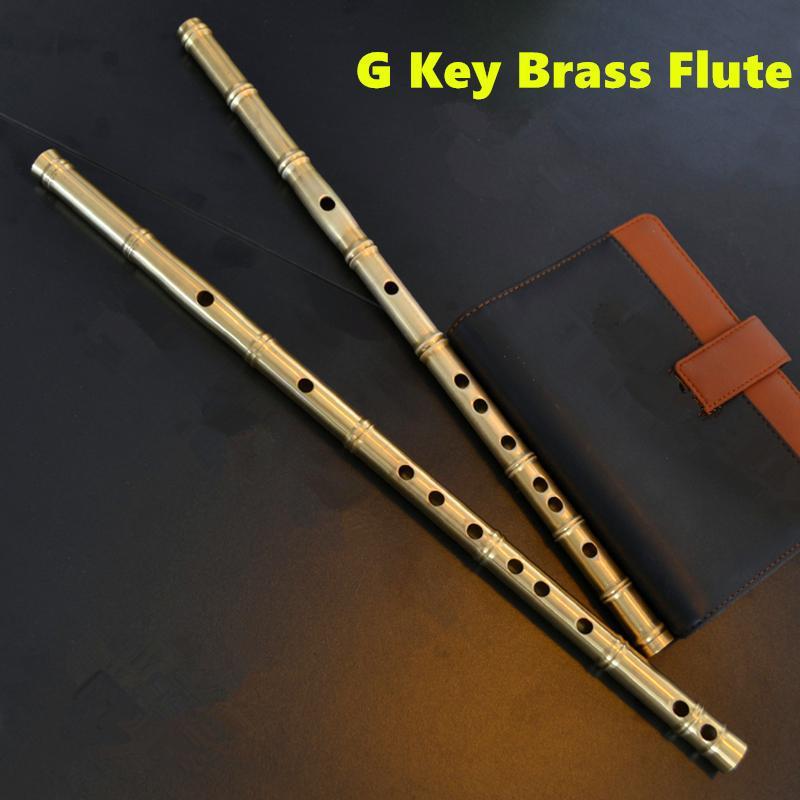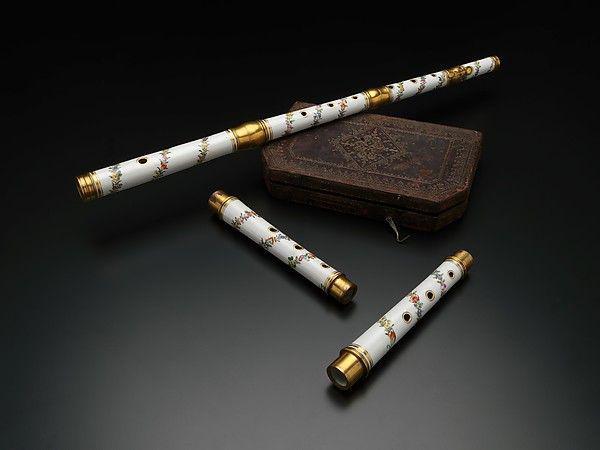The first image is the image on the left, the second image is the image on the right. For the images shown, is this caption "There is a white flute." true? Answer yes or no. Yes. The first image is the image on the left, the second image is the image on the right. Analyze the images presented: Is the assertion "The picture on the left shows exactly two flutes side by side." valid? Answer yes or no. Yes. 